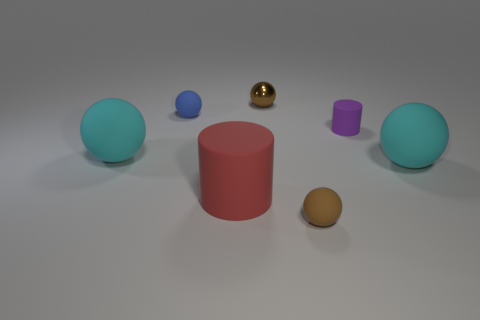Are there an equal number of spheres in front of the purple cylinder and large cyan matte objects?
Offer a very short reply. No. How many other objects are there of the same size as the shiny thing?
Offer a very short reply. 3. Does the small brown thing that is behind the brown rubber ball have the same material as the small ball that is on the left side of the big cylinder?
Keep it short and to the point. No. There is a cylinder that is in front of the matte thing on the right side of the small purple matte thing; what size is it?
Provide a short and direct response. Large. Is there another sphere that has the same color as the small metallic sphere?
Provide a succinct answer. Yes. Is the color of the big matte object that is on the right side of the tiny brown matte object the same as the large sphere on the left side of the brown rubber sphere?
Keep it short and to the point. Yes. The brown rubber thing is what shape?
Provide a short and direct response. Sphere. What number of tiny brown shiny things are behind the tiny shiny thing?
Your response must be concise. 0. What number of large cyan balls have the same material as the big red cylinder?
Offer a terse response. 2. Are the cyan object that is on the right side of the small purple rubber cylinder and the purple cylinder made of the same material?
Your answer should be very brief. Yes. 